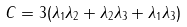<formula> <loc_0><loc_0><loc_500><loc_500>C = 3 ( \lambda _ { 1 } \lambda _ { 2 } + \lambda _ { 2 } \lambda _ { 3 } + \lambda _ { 1 } \lambda _ { 3 } )</formula> 